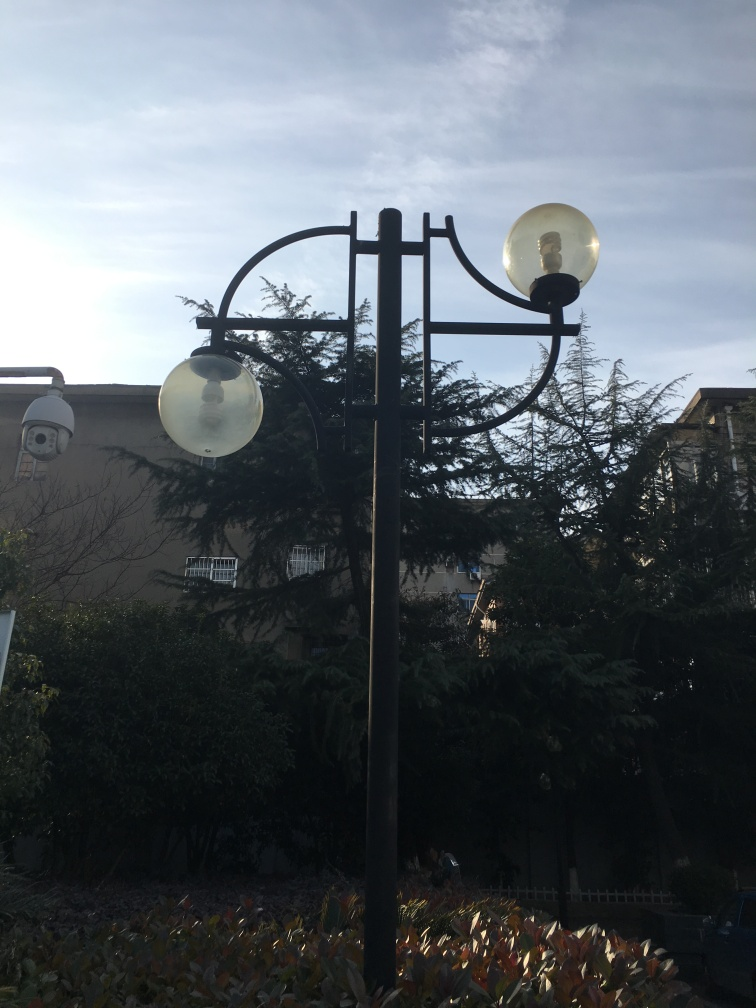What style or era does the streetlamp design suggest? The streetlamp in the image has a classic design, reminiscent of the Victorian era with its iron wrought details and spherical lampshades. This style is often regarded as timeless and is frequently used to evoke a sense of elegance and history in public spaces. 